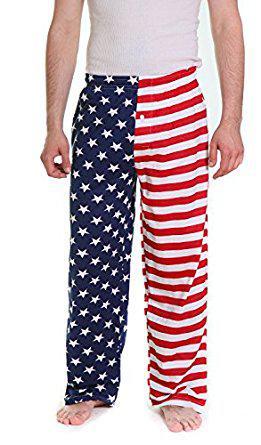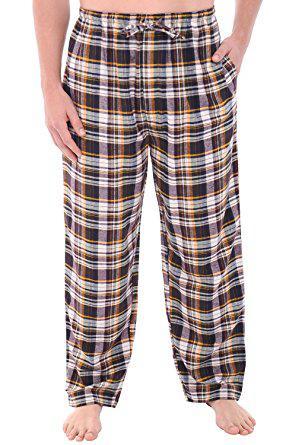The first image is the image on the left, the second image is the image on the right. Considering the images on both sides, is "One pair of pajama pants is a solid color." valid? Answer yes or no. No. 